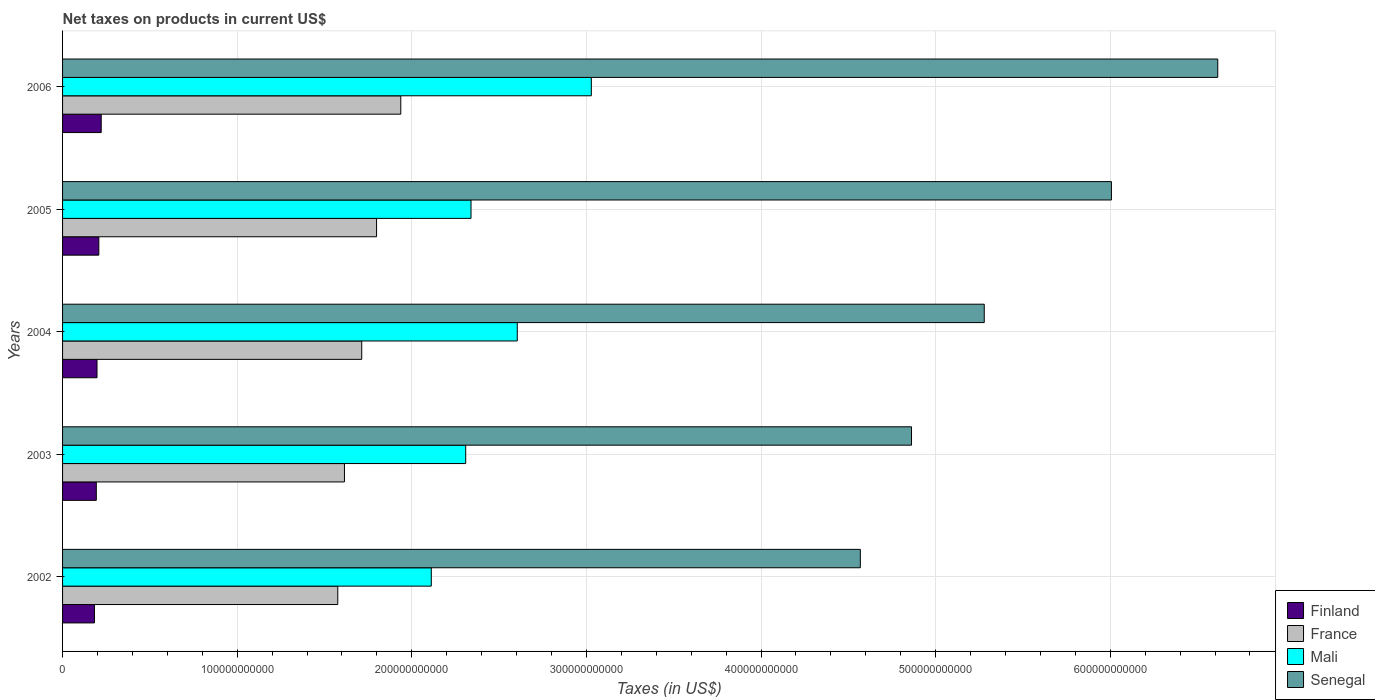How many different coloured bars are there?
Your answer should be compact. 4. How many groups of bars are there?
Provide a succinct answer. 5. Are the number of bars per tick equal to the number of legend labels?
Ensure brevity in your answer.  Yes. How many bars are there on the 4th tick from the top?
Your answer should be compact. 4. What is the net taxes on products in Senegal in 2003?
Give a very brief answer. 4.86e+11. Across all years, what is the maximum net taxes on products in Mali?
Your answer should be very brief. 3.03e+11. Across all years, what is the minimum net taxes on products in Senegal?
Provide a short and direct response. 4.57e+11. In which year was the net taxes on products in Mali maximum?
Your response must be concise. 2006. What is the total net taxes on products in Mali in the graph?
Your answer should be very brief. 1.24e+12. What is the difference between the net taxes on products in France in 2003 and that in 2006?
Give a very brief answer. -3.23e+1. What is the difference between the net taxes on products in Finland in 2005 and the net taxes on products in Senegal in 2003?
Make the answer very short. -4.65e+11. What is the average net taxes on products in France per year?
Your answer should be compact. 1.73e+11. In the year 2005, what is the difference between the net taxes on products in Finland and net taxes on products in Mali?
Keep it short and to the point. -2.13e+11. What is the ratio of the net taxes on products in Finland in 2002 to that in 2006?
Keep it short and to the point. 0.83. Is the net taxes on products in France in 2004 less than that in 2005?
Keep it short and to the point. Yes. Is the difference between the net taxes on products in Finland in 2002 and 2003 greater than the difference between the net taxes on products in Mali in 2002 and 2003?
Your response must be concise. Yes. What is the difference between the highest and the second highest net taxes on products in France?
Provide a short and direct response. 1.39e+1. What is the difference between the highest and the lowest net taxes on products in Finland?
Your response must be concise. 3.87e+09. In how many years, is the net taxes on products in Senegal greater than the average net taxes on products in Senegal taken over all years?
Your response must be concise. 2. What does the 2nd bar from the top in 2003 represents?
Make the answer very short. Mali. What does the 1st bar from the bottom in 2005 represents?
Keep it short and to the point. Finland. How many bars are there?
Offer a very short reply. 20. How many years are there in the graph?
Give a very brief answer. 5. What is the difference between two consecutive major ticks on the X-axis?
Your answer should be very brief. 1.00e+11. Are the values on the major ticks of X-axis written in scientific E-notation?
Give a very brief answer. No. Does the graph contain grids?
Provide a succinct answer. Yes. What is the title of the graph?
Provide a short and direct response. Net taxes on products in current US$. What is the label or title of the X-axis?
Provide a succinct answer. Taxes (in US$). What is the Taxes (in US$) of Finland in 2002?
Ensure brevity in your answer.  1.83e+1. What is the Taxes (in US$) in France in 2002?
Provide a short and direct response. 1.58e+11. What is the Taxes (in US$) in Mali in 2002?
Your answer should be compact. 2.11e+11. What is the Taxes (in US$) of Senegal in 2002?
Provide a succinct answer. 4.57e+11. What is the Taxes (in US$) in Finland in 2003?
Your answer should be compact. 1.93e+1. What is the Taxes (in US$) of France in 2003?
Provide a succinct answer. 1.61e+11. What is the Taxes (in US$) in Mali in 2003?
Keep it short and to the point. 2.31e+11. What is the Taxes (in US$) in Senegal in 2003?
Offer a terse response. 4.86e+11. What is the Taxes (in US$) in Finland in 2004?
Make the answer very short. 1.97e+1. What is the Taxes (in US$) in France in 2004?
Your answer should be very brief. 1.71e+11. What is the Taxes (in US$) in Mali in 2004?
Offer a very short reply. 2.60e+11. What is the Taxes (in US$) of Senegal in 2004?
Keep it short and to the point. 5.28e+11. What is the Taxes (in US$) in Finland in 2005?
Your response must be concise. 2.08e+1. What is the Taxes (in US$) in France in 2005?
Your answer should be very brief. 1.80e+11. What is the Taxes (in US$) in Mali in 2005?
Ensure brevity in your answer.  2.34e+11. What is the Taxes (in US$) of Senegal in 2005?
Give a very brief answer. 6.01e+11. What is the Taxes (in US$) in Finland in 2006?
Your response must be concise. 2.21e+1. What is the Taxes (in US$) in France in 2006?
Your response must be concise. 1.94e+11. What is the Taxes (in US$) in Mali in 2006?
Provide a succinct answer. 3.03e+11. What is the Taxes (in US$) in Senegal in 2006?
Your response must be concise. 6.62e+11. Across all years, what is the maximum Taxes (in US$) in Finland?
Your response must be concise. 2.21e+1. Across all years, what is the maximum Taxes (in US$) in France?
Offer a terse response. 1.94e+11. Across all years, what is the maximum Taxes (in US$) in Mali?
Keep it short and to the point. 3.03e+11. Across all years, what is the maximum Taxes (in US$) of Senegal?
Provide a short and direct response. 6.62e+11. Across all years, what is the minimum Taxes (in US$) of Finland?
Give a very brief answer. 1.83e+1. Across all years, what is the minimum Taxes (in US$) of France?
Offer a very short reply. 1.58e+11. Across all years, what is the minimum Taxes (in US$) of Mali?
Give a very brief answer. 2.11e+11. Across all years, what is the minimum Taxes (in US$) of Senegal?
Keep it short and to the point. 4.57e+11. What is the total Taxes (in US$) of Finland in the graph?
Provide a succinct answer. 1.00e+11. What is the total Taxes (in US$) of France in the graph?
Offer a terse response. 8.64e+11. What is the total Taxes (in US$) of Mali in the graph?
Provide a succinct answer. 1.24e+12. What is the total Taxes (in US$) of Senegal in the graph?
Provide a short and direct response. 2.73e+12. What is the difference between the Taxes (in US$) of Finland in 2002 and that in 2003?
Make the answer very short. -1.06e+09. What is the difference between the Taxes (in US$) of France in 2002 and that in 2003?
Offer a terse response. -3.82e+09. What is the difference between the Taxes (in US$) of Mali in 2002 and that in 2003?
Your response must be concise. -1.97e+1. What is the difference between the Taxes (in US$) in Senegal in 2002 and that in 2003?
Ensure brevity in your answer.  -2.93e+1. What is the difference between the Taxes (in US$) of Finland in 2002 and that in 2004?
Provide a short and direct response. -1.46e+09. What is the difference between the Taxes (in US$) of France in 2002 and that in 2004?
Your answer should be compact. -1.37e+1. What is the difference between the Taxes (in US$) in Mali in 2002 and that in 2004?
Offer a very short reply. -4.92e+1. What is the difference between the Taxes (in US$) of Senegal in 2002 and that in 2004?
Provide a short and direct response. -7.10e+1. What is the difference between the Taxes (in US$) in Finland in 2002 and that in 2005?
Make the answer very short. -2.50e+09. What is the difference between the Taxes (in US$) in France in 2002 and that in 2005?
Offer a terse response. -2.22e+1. What is the difference between the Taxes (in US$) in Mali in 2002 and that in 2005?
Your answer should be very brief. -2.28e+1. What is the difference between the Taxes (in US$) in Senegal in 2002 and that in 2005?
Ensure brevity in your answer.  -1.44e+11. What is the difference between the Taxes (in US$) of Finland in 2002 and that in 2006?
Make the answer very short. -3.87e+09. What is the difference between the Taxes (in US$) of France in 2002 and that in 2006?
Keep it short and to the point. -3.61e+1. What is the difference between the Taxes (in US$) of Mali in 2002 and that in 2006?
Make the answer very short. -9.17e+1. What is the difference between the Taxes (in US$) in Senegal in 2002 and that in 2006?
Give a very brief answer. -2.05e+11. What is the difference between the Taxes (in US$) of Finland in 2003 and that in 2004?
Make the answer very short. -3.99e+08. What is the difference between the Taxes (in US$) of France in 2003 and that in 2004?
Your answer should be very brief. -9.90e+09. What is the difference between the Taxes (in US$) in Mali in 2003 and that in 2004?
Keep it short and to the point. -2.95e+1. What is the difference between the Taxes (in US$) in Senegal in 2003 and that in 2004?
Keep it short and to the point. -4.17e+1. What is the difference between the Taxes (in US$) in Finland in 2003 and that in 2005?
Provide a succinct answer. -1.44e+09. What is the difference between the Taxes (in US$) of France in 2003 and that in 2005?
Provide a succinct answer. -1.84e+1. What is the difference between the Taxes (in US$) in Mali in 2003 and that in 2005?
Your answer should be very brief. -3.04e+09. What is the difference between the Taxes (in US$) in Senegal in 2003 and that in 2005?
Provide a short and direct response. -1.14e+11. What is the difference between the Taxes (in US$) in Finland in 2003 and that in 2006?
Provide a short and direct response. -2.81e+09. What is the difference between the Taxes (in US$) in France in 2003 and that in 2006?
Your response must be concise. -3.23e+1. What is the difference between the Taxes (in US$) of Mali in 2003 and that in 2006?
Provide a succinct answer. -7.19e+1. What is the difference between the Taxes (in US$) of Senegal in 2003 and that in 2006?
Keep it short and to the point. -1.75e+11. What is the difference between the Taxes (in US$) of Finland in 2004 and that in 2005?
Your answer should be very brief. -1.04e+09. What is the difference between the Taxes (in US$) in France in 2004 and that in 2005?
Keep it short and to the point. -8.49e+09. What is the difference between the Taxes (in US$) of Mali in 2004 and that in 2005?
Make the answer very short. 2.65e+1. What is the difference between the Taxes (in US$) of Senegal in 2004 and that in 2005?
Offer a very short reply. -7.28e+1. What is the difference between the Taxes (in US$) of Finland in 2004 and that in 2006?
Ensure brevity in your answer.  -2.41e+09. What is the difference between the Taxes (in US$) of France in 2004 and that in 2006?
Make the answer very short. -2.24e+1. What is the difference between the Taxes (in US$) in Mali in 2004 and that in 2006?
Make the answer very short. -4.24e+1. What is the difference between the Taxes (in US$) in Senegal in 2004 and that in 2006?
Keep it short and to the point. -1.34e+11. What is the difference between the Taxes (in US$) in Finland in 2005 and that in 2006?
Ensure brevity in your answer.  -1.37e+09. What is the difference between the Taxes (in US$) of France in 2005 and that in 2006?
Provide a short and direct response. -1.39e+1. What is the difference between the Taxes (in US$) in Mali in 2005 and that in 2006?
Make the answer very short. -6.89e+1. What is the difference between the Taxes (in US$) of Senegal in 2005 and that in 2006?
Provide a succinct answer. -6.09e+1. What is the difference between the Taxes (in US$) in Finland in 2002 and the Taxes (in US$) in France in 2003?
Offer a very short reply. -1.43e+11. What is the difference between the Taxes (in US$) of Finland in 2002 and the Taxes (in US$) of Mali in 2003?
Give a very brief answer. -2.13e+11. What is the difference between the Taxes (in US$) of Finland in 2002 and the Taxes (in US$) of Senegal in 2003?
Your answer should be very brief. -4.68e+11. What is the difference between the Taxes (in US$) of France in 2002 and the Taxes (in US$) of Mali in 2003?
Keep it short and to the point. -7.33e+1. What is the difference between the Taxes (in US$) of France in 2002 and the Taxes (in US$) of Senegal in 2003?
Offer a terse response. -3.29e+11. What is the difference between the Taxes (in US$) in Mali in 2002 and the Taxes (in US$) in Senegal in 2003?
Provide a succinct answer. -2.75e+11. What is the difference between the Taxes (in US$) in Finland in 2002 and the Taxes (in US$) in France in 2004?
Give a very brief answer. -1.53e+11. What is the difference between the Taxes (in US$) of Finland in 2002 and the Taxes (in US$) of Mali in 2004?
Your response must be concise. -2.42e+11. What is the difference between the Taxes (in US$) in Finland in 2002 and the Taxes (in US$) in Senegal in 2004?
Offer a very short reply. -5.10e+11. What is the difference between the Taxes (in US$) of France in 2002 and the Taxes (in US$) of Mali in 2004?
Your answer should be compact. -1.03e+11. What is the difference between the Taxes (in US$) in France in 2002 and the Taxes (in US$) in Senegal in 2004?
Make the answer very short. -3.70e+11. What is the difference between the Taxes (in US$) of Mali in 2002 and the Taxes (in US$) of Senegal in 2004?
Provide a succinct answer. -3.17e+11. What is the difference between the Taxes (in US$) in Finland in 2002 and the Taxes (in US$) in France in 2005?
Your response must be concise. -1.62e+11. What is the difference between the Taxes (in US$) in Finland in 2002 and the Taxes (in US$) in Mali in 2005?
Give a very brief answer. -2.16e+11. What is the difference between the Taxes (in US$) of Finland in 2002 and the Taxes (in US$) of Senegal in 2005?
Make the answer very short. -5.82e+11. What is the difference between the Taxes (in US$) in France in 2002 and the Taxes (in US$) in Mali in 2005?
Offer a terse response. -7.63e+1. What is the difference between the Taxes (in US$) in France in 2002 and the Taxes (in US$) in Senegal in 2005?
Give a very brief answer. -4.43e+11. What is the difference between the Taxes (in US$) in Mali in 2002 and the Taxes (in US$) in Senegal in 2005?
Keep it short and to the point. -3.89e+11. What is the difference between the Taxes (in US$) in Finland in 2002 and the Taxes (in US$) in France in 2006?
Provide a succinct answer. -1.75e+11. What is the difference between the Taxes (in US$) in Finland in 2002 and the Taxes (in US$) in Mali in 2006?
Make the answer very short. -2.85e+11. What is the difference between the Taxes (in US$) in Finland in 2002 and the Taxes (in US$) in Senegal in 2006?
Offer a very short reply. -6.43e+11. What is the difference between the Taxes (in US$) in France in 2002 and the Taxes (in US$) in Mali in 2006?
Give a very brief answer. -1.45e+11. What is the difference between the Taxes (in US$) of France in 2002 and the Taxes (in US$) of Senegal in 2006?
Offer a very short reply. -5.04e+11. What is the difference between the Taxes (in US$) in Mali in 2002 and the Taxes (in US$) in Senegal in 2006?
Provide a short and direct response. -4.50e+11. What is the difference between the Taxes (in US$) in Finland in 2003 and the Taxes (in US$) in France in 2004?
Provide a short and direct response. -1.52e+11. What is the difference between the Taxes (in US$) in Finland in 2003 and the Taxes (in US$) in Mali in 2004?
Your answer should be compact. -2.41e+11. What is the difference between the Taxes (in US$) in Finland in 2003 and the Taxes (in US$) in Senegal in 2004?
Make the answer very short. -5.09e+11. What is the difference between the Taxes (in US$) in France in 2003 and the Taxes (in US$) in Mali in 2004?
Give a very brief answer. -9.90e+1. What is the difference between the Taxes (in US$) in France in 2003 and the Taxes (in US$) in Senegal in 2004?
Provide a short and direct response. -3.66e+11. What is the difference between the Taxes (in US$) of Mali in 2003 and the Taxes (in US$) of Senegal in 2004?
Make the answer very short. -2.97e+11. What is the difference between the Taxes (in US$) of Finland in 2003 and the Taxes (in US$) of France in 2005?
Your response must be concise. -1.60e+11. What is the difference between the Taxes (in US$) in Finland in 2003 and the Taxes (in US$) in Mali in 2005?
Give a very brief answer. -2.15e+11. What is the difference between the Taxes (in US$) of Finland in 2003 and the Taxes (in US$) of Senegal in 2005?
Your answer should be compact. -5.81e+11. What is the difference between the Taxes (in US$) in France in 2003 and the Taxes (in US$) in Mali in 2005?
Keep it short and to the point. -7.25e+1. What is the difference between the Taxes (in US$) in France in 2003 and the Taxes (in US$) in Senegal in 2005?
Offer a very short reply. -4.39e+11. What is the difference between the Taxes (in US$) of Mali in 2003 and the Taxes (in US$) of Senegal in 2005?
Offer a terse response. -3.70e+11. What is the difference between the Taxes (in US$) of Finland in 2003 and the Taxes (in US$) of France in 2006?
Ensure brevity in your answer.  -1.74e+11. What is the difference between the Taxes (in US$) in Finland in 2003 and the Taxes (in US$) in Mali in 2006?
Give a very brief answer. -2.83e+11. What is the difference between the Taxes (in US$) in Finland in 2003 and the Taxes (in US$) in Senegal in 2006?
Your response must be concise. -6.42e+11. What is the difference between the Taxes (in US$) of France in 2003 and the Taxes (in US$) of Mali in 2006?
Your answer should be compact. -1.41e+11. What is the difference between the Taxes (in US$) in France in 2003 and the Taxes (in US$) in Senegal in 2006?
Your response must be concise. -5.00e+11. What is the difference between the Taxes (in US$) in Mali in 2003 and the Taxes (in US$) in Senegal in 2006?
Ensure brevity in your answer.  -4.31e+11. What is the difference between the Taxes (in US$) of Finland in 2004 and the Taxes (in US$) of France in 2005?
Offer a terse response. -1.60e+11. What is the difference between the Taxes (in US$) in Finland in 2004 and the Taxes (in US$) in Mali in 2005?
Your answer should be very brief. -2.14e+11. What is the difference between the Taxes (in US$) in Finland in 2004 and the Taxes (in US$) in Senegal in 2005?
Make the answer very short. -5.81e+11. What is the difference between the Taxes (in US$) in France in 2004 and the Taxes (in US$) in Mali in 2005?
Make the answer very short. -6.26e+1. What is the difference between the Taxes (in US$) of France in 2004 and the Taxes (in US$) of Senegal in 2005?
Keep it short and to the point. -4.29e+11. What is the difference between the Taxes (in US$) in Mali in 2004 and the Taxes (in US$) in Senegal in 2005?
Provide a succinct answer. -3.40e+11. What is the difference between the Taxes (in US$) of Finland in 2004 and the Taxes (in US$) of France in 2006?
Provide a succinct answer. -1.74e+11. What is the difference between the Taxes (in US$) in Finland in 2004 and the Taxes (in US$) in Mali in 2006?
Provide a succinct answer. -2.83e+11. What is the difference between the Taxes (in US$) in Finland in 2004 and the Taxes (in US$) in Senegal in 2006?
Your answer should be very brief. -6.42e+11. What is the difference between the Taxes (in US$) in France in 2004 and the Taxes (in US$) in Mali in 2006?
Give a very brief answer. -1.31e+11. What is the difference between the Taxes (in US$) of France in 2004 and the Taxes (in US$) of Senegal in 2006?
Your answer should be very brief. -4.90e+11. What is the difference between the Taxes (in US$) of Mali in 2004 and the Taxes (in US$) of Senegal in 2006?
Your answer should be very brief. -4.01e+11. What is the difference between the Taxes (in US$) of Finland in 2005 and the Taxes (in US$) of France in 2006?
Provide a succinct answer. -1.73e+11. What is the difference between the Taxes (in US$) in Finland in 2005 and the Taxes (in US$) in Mali in 2006?
Offer a terse response. -2.82e+11. What is the difference between the Taxes (in US$) of Finland in 2005 and the Taxes (in US$) of Senegal in 2006?
Your response must be concise. -6.41e+11. What is the difference between the Taxes (in US$) in France in 2005 and the Taxes (in US$) in Mali in 2006?
Your response must be concise. -1.23e+11. What is the difference between the Taxes (in US$) of France in 2005 and the Taxes (in US$) of Senegal in 2006?
Provide a short and direct response. -4.82e+11. What is the difference between the Taxes (in US$) in Mali in 2005 and the Taxes (in US$) in Senegal in 2006?
Make the answer very short. -4.28e+11. What is the average Taxes (in US$) in Finland per year?
Ensure brevity in your answer.  2.00e+1. What is the average Taxes (in US$) of France per year?
Ensure brevity in your answer.  1.73e+11. What is the average Taxes (in US$) in Mali per year?
Give a very brief answer. 2.48e+11. What is the average Taxes (in US$) of Senegal per year?
Your response must be concise. 5.47e+11. In the year 2002, what is the difference between the Taxes (in US$) of Finland and Taxes (in US$) of France?
Give a very brief answer. -1.39e+11. In the year 2002, what is the difference between the Taxes (in US$) in Finland and Taxes (in US$) in Mali?
Your answer should be compact. -1.93e+11. In the year 2002, what is the difference between the Taxes (in US$) in Finland and Taxes (in US$) in Senegal?
Offer a very short reply. -4.39e+11. In the year 2002, what is the difference between the Taxes (in US$) in France and Taxes (in US$) in Mali?
Provide a succinct answer. -5.36e+1. In the year 2002, what is the difference between the Taxes (in US$) of France and Taxes (in US$) of Senegal?
Offer a terse response. -2.99e+11. In the year 2002, what is the difference between the Taxes (in US$) in Mali and Taxes (in US$) in Senegal?
Your answer should be compact. -2.46e+11. In the year 2003, what is the difference between the Taxes (in US$) in Finland and Taxes (in US$) in France?
Your answer should be very brief. -1.42e+11. In the year 2003, what is the difference between the Taxes (in US$) of Finland and Taxes (in US$) of Mali?
Offer a very short reply. -2.12e+11. In the year 2003, what is the difference between the Taxes (in US$) in Finland and Taxes (in US$) in Senegal?
Make the answer very short. -4.67e+11. In the year 2003, what is the difference between the Taxes (in US$) of France and Taxes (in US$) of Mali?
Provide a short and direct response. -6.94e+1. In the year 2003, what is the difference between the Taxes (in US$) of France and Taxes (in US$) of Senegal?
Provide a short and direct response. -3.25e+11. In the year 2003, what is the difference between the Taxes (in US$) of Mali and Taxes (in US$) of Senegal?
Your answer should be compact. -2.55e+11. In the year 2004, what is the difference between the Taxes (in US$) of Finland and Taxes (in US$) of France?
Your answer should be very brief. -1.52e+11. In the year 2004, what is the difference between the Taxes (in US$) of Finland and Taxes (in US$) of Mali?
Give a very brief answer. -2.41e+11. In the year 2004, what is the difference between the Taxes (in US$) of Finland and Taxes (in US$) of Senegal?
Offer a terse response. -5.08e+11. In the year 2004, what is the difference between the Taxes (in US$) of France and Taxes (in US$) of Mali?
Give a very brief answer. -8.91e+1. In the year 2004, what is the difference between the Taxes (in US$) of France and Taxes (in US$) of Senegal?
Provide a succinct answer. -3.57e+11. In the year 2004, what is the difference between the Taxes (in US$) of Mali and Taxes (in US$) of Senegal?
Provide a succinct answer. -2.67e+11. In the year 2005, what is the difference between the Taxes (in US$) in Finland and Taxes (in US$) in France?
Provide a short and direct response. -1.59e+11. In the year 2005, what is the difference between the Taxes (in US$) in Finland and Taxes (in US$) in Mali?
Provide a succinct answer. -2.13e+11. In the year 2005, what is the difference between the Taxes (in US$) of Finland and Taxes (in US$) of Senegal?
Ensure brevity in your answer.  -5.80e+11. In the year 2005, what is the difference between the Taxes (in US$) in France and Taxes (in US$) in Mali?
Offer a very short reply. -5.41e+1. In the year 2005, what is the difference between the Taxes (in US$) of France and Taxes (in US$) of Senegal?
Your answer should be very brief. -4.21e+11. In the year 2005, what is the difference between the Taxes (in US$) of Mali and Taxes (in US$) of Senegal?
Offer a terse response. -3.67e+11. In the year 2006, what is the difference between the Taxes (in US$) in Finland and Taxes (in US$) in France?
Offer a terse response. -1.72e+11. In the year 2006, what is the difference between the Taxes (in US$) in Finland and Taxes (in US$) in Mali?
Offer a very short reply. -2.81e+11. In the year 2006, what is the difference between the Taxes (in US$) in Finland and Taxes (in US$) in Senegal?
Make the answer very short. -6.39e+11. In the year 2006, what is the difference between the Taxes (in US$) in France and Taxes (in US$) in Mali?
Make the answer very short. -1.09e+11. In the year 2006, what is the difference between the Taxes (in US$) of France and Taxes (in US$) of Senegal?
Give a very brief answer. -4.68e+11. In the year 2006, what is the difference between the Taxes (in US$) of Mali and Taxes (in US$) of Senegal?
Offer a terse response. -3.59e+11. What is the ratio of the Taxes (in US$) in Finland in 2002 to that in 2003?
Your answer should be very brief. 0.95. What is the ratio of the Taxes (in US$) of France in 2002 to that in 2003?
Ensure brevity in your answer.  0.98. What is the ratio of the Taxes (in US$) of Mali in 2002 to that in 2003?
Make the answer very short. 0.91. What is the ratio of the Taxes (in US$) of Senegal in 2002 to that in 2003?
Give a very brief answer. 0.94. What is the ratio of the Taxes (in US$) of Finland in 2002 to that in 2004?
Make the answer very short. 0.93. What is the ratio of the Taxes (in US$) of France in 2002 to that in 2004?
Provide a short and direct response. 0.92. What is the ratio of the Taxes (in US$) of Mali in 2002 to that in 2004?
Provide a succinct answer. 0.81. What is the ratio of the Taxes (in US$) of Senegal in 2002 to that in 2004?
Your answer should be very brief. 0.87. What is the ratio of the Taxes (in US$) in Finland in 2002 to that in 2005?
Ensure brevity in your answer.  0.88. What is the ratio of the Taxes (in US$) of France in 2002 to that in 2005?
Make the answer very short. 0.88. What is the ratio of the Taxes (in US$) in Mali in 2002 to that in 2005?
Your answer should be very brief. 0.9. What is the ratio of the Taxes (in US$) in Senegal in 2002 to that in 2005?
Your answer should be very brief. 0.76. What is the ratio of the Taxes (in US$) of Finland in 2002 to that in 2006?
Keep it short and to the point. 0.83. What is the ratio of the Taxes (in US$) of France in 2002 to that in 2006?
Offer a terse response. 0.81. What is the ratio of the Taxes (in US$) in Mali in 2002 to that in 2006?
Your response must be concise. 0.7. What is the ratio of the Taxes (in US$) in Senegal in 2002 to that in 2006?
Provide a short and direct response. 0.69. What is the ratio of the Taxes (in US$) of Finland in 2003 to that in 2004?
Give a very brief answer. 0.98. What is the ratio of the Taxes (in US$) of France in 2003 to that in 2004?
Keep it short and to the point. 0.94. What is the ratio of the Taxes (in US$) in Mali in 2003 to that in 2004?
Provide a succinct answer. 0.89. What is the ratio of the Taxes (in US$) in Senegal in 2003 to that in 2004?
Your answer should be compact. 0.92. What is the ratio of the Taxes (in US$) of Finland in 2003 to that in 2005?
Your answer should be compact. 0.93. What is the ratio of the Taxes (in US$) of France in 2003 to that in 2005?
Your response must be concise. 0.9. What is the ratio of the Taxes (in US$) of Mali in 2003 to that in 2005?
Keep it short and to the point. 0.99. What is the ratio of the Taxes (in US$) in Senegal in 2003 to that in 2005?
Offer a very short reply. 0.81. What is the ratio of the Taxes (in US$) of Finland in 2003 to that in 2006?
Make the answer very short. 0.87. What is the ratio of the Taxes (in US$) in France in 2003 to that in 2006?
Offer a very short reply. 0.83. What is the ratio of the Taxes (in US$) in Mali in 2003 to that in 2006?
Offer a very short reply. 0.76. What is the ratio of the Taxes (in US$) of Senegal in 2003 to that in 2006?
Your answer should be compact. 0.73. What is the ratio of the Taxes (in US$) in Finland in 2004 to that in 2005?
Ensure brevity in your answer.  0.95. What is the ratio of the Taxes (in US$) in France in 2004 to that in 2005?
Offer a very short reply. 0.95. What is the ratio of the Taxes (in US$) of Mali in 2004 to that in 2005?
Your answer should be compact. 1.11. What is the ratio of the Taxes (in US$) of Senegal in 2004 to that in 2005?
Your response must be concise. 0.88. What is the ratio of the Taxes (in US$) in Finland in 2004 to that in 2006?
Offer a terse response. 0.89. What is the ratio of the Taxes (in US$) in France in 2004 to that in 2006?
Ensure brevity in your answer.  0.88. What is the ratio of the Taxes (in US$) of Mali in 2004 to that in 2006?
Your answer should be very brief. 0.86. What is the ratio of the Taxes (in US$) of Senegal in 2004 to that in 2006?
Your response must be concise. 0.8. What is the ratio of the Taxes (in US$) of Finland in 2005 to that in 2006?
Your response must be concise. 0.94. What is the ratio of the Taxes (in US$) of France in 2005 to that in 2006?
Your answer should be very brief. 0.93. What is the ratio of the Taxes (in US$) in Mali in 2005 to that in 2006?
Give a very brief answer. 0.77. What is the ratio of the Taxes (in US$) of Senegal in 2005 to that in 2006?
Ensure brevity in your answer.  0.91. What is the difference between the highest and the second highest Taxes (in US$) in Finland?
Give a very brief answer. 1.37e+09. What is the difference between the highest and the second highest Taxes (in US$) in France?
Your answer should be compact. 1.39e+1. What is the difference between the highest and the second highest Taxes (in US$) of Mali?
Your answer should be compact. 4.24e+1. What is the difference between the highest and the second highest Taxes (in US$) in Senegal?
Keep it short and to the point. 6.09e+1. What is the difference between the highest and the lowest Taxes (in US$) of Finland?
Provide a succinct answer. 3.87e+09. What is the difference between the highest and the lowest Taxes (in US$) in France?
Make the answer very short. 3.61e+1. What is the difference between the highest and the lowest Taxes (in US$) in Mali?
Make the answer very short. 9.17e+1. What is the difference between the highest and the lowest Taxes (in US$) in Senegal?
Your response must be concise. 2.05e+11. 